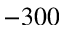<formula> <loc_0><loc_0><loc_500><loc_500>- 3 0 0</formula> 